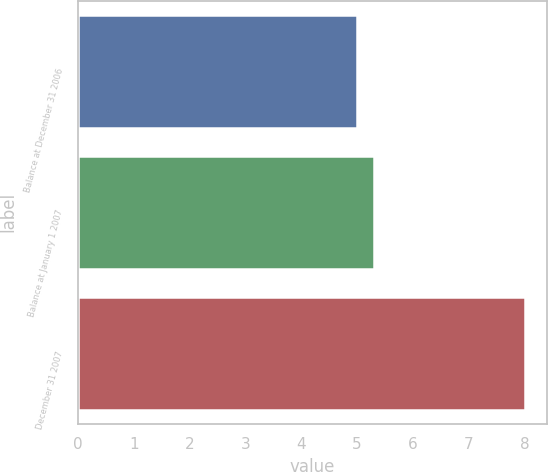Convert chart to OTSL. <chart><loc_0><loc_0><loc_500><loc_500><bar_chart><fcel>Balance at December 31 2006<fcel>Balance at January 1 2007<fcel>December 31 2007<nl><fcel>5<fcel>5.3<fcel>8<nl></chart> 